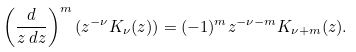Convert formula to latex. <formula><loc_0><loc_0><loc_500><loc_500>\left ( \frac { d } { z \, d z } \right ) ^ { m } ( z ^ { - \nu } K _ { \nu } ( z ) ) = ( - 1 ) ^ { m } z ^ { - \nu - m } K _ { \nu + m } ( z ) .</formula> 